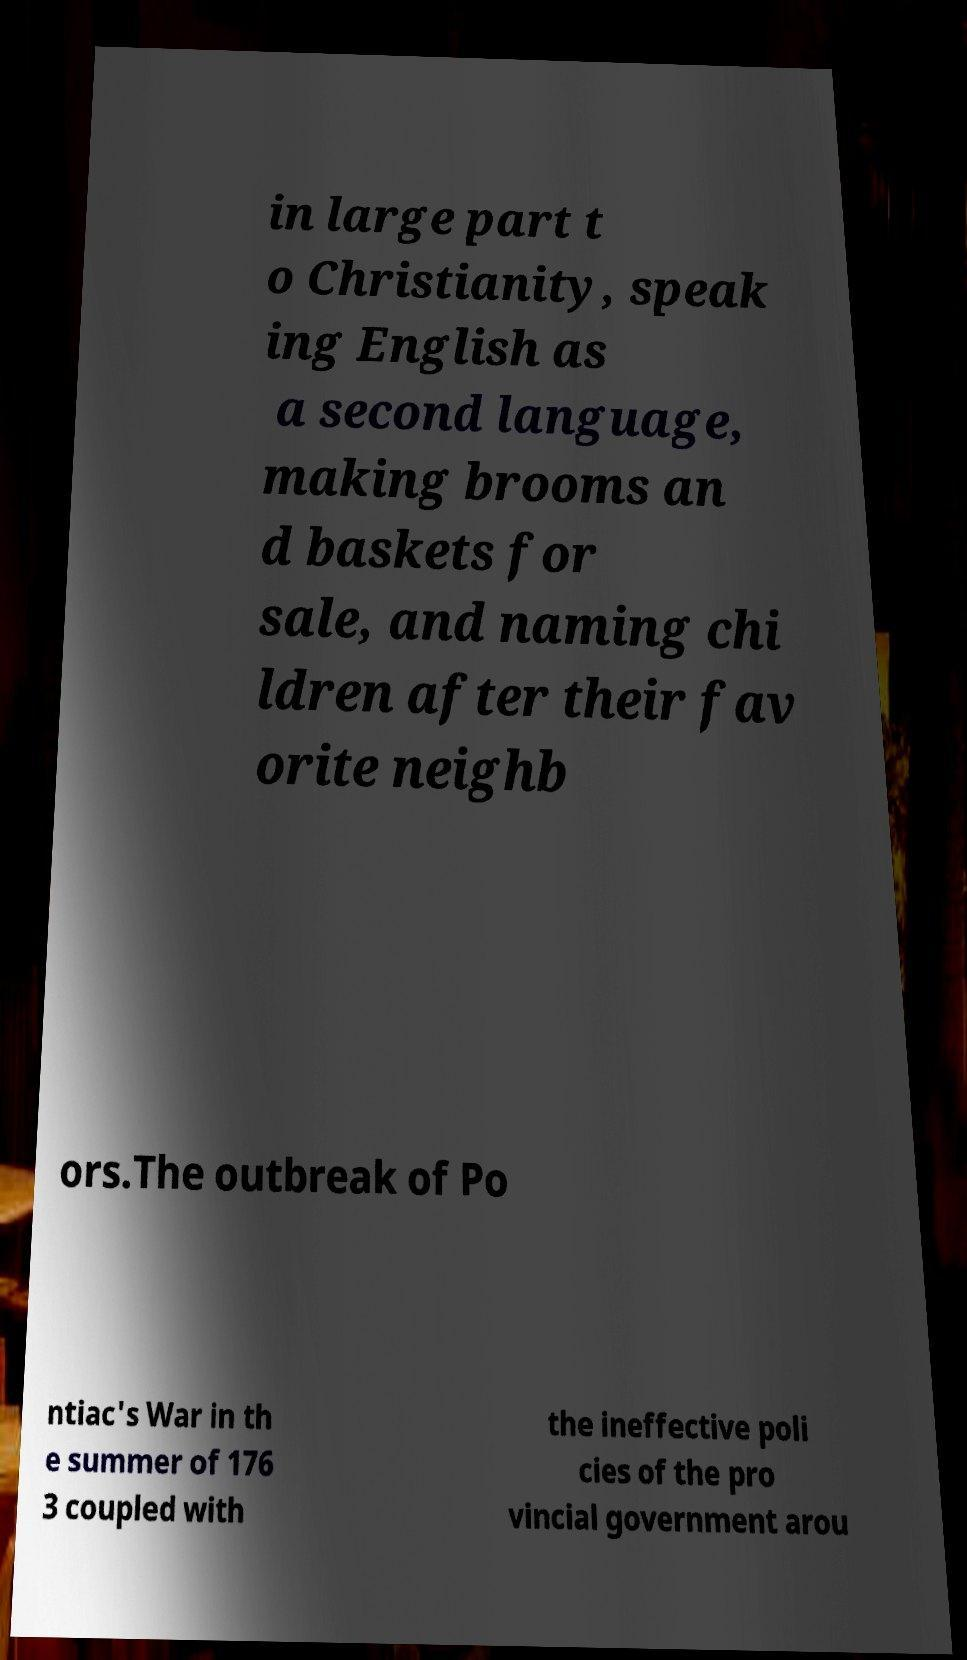There's text embedded in this image that I need extracted. Can you transcribe it verbatim? in large part t o Christianity, speak ing English as a second language, making brooms an d baskets for sale, and naming chi ldren after their fav orite neighb ors.The outbreak of Po ntiac's War in th e summer of 176 3 coupled with the ineffective poli cies of the pro vincial government arou 